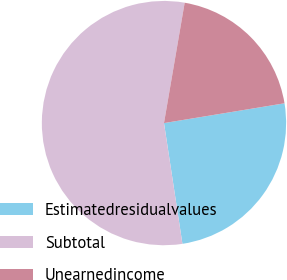Convert chart to OTSL. <chart><loc_0><loc_0><loc_500><loc_500><pie_chart><fcel>Estimatedresidualvalues<fcel>Subtotal<fcel>Unearnedincome<nl><fcel>25.18%<fcel>55.12%<fcel>19.7%<nl></chart> 